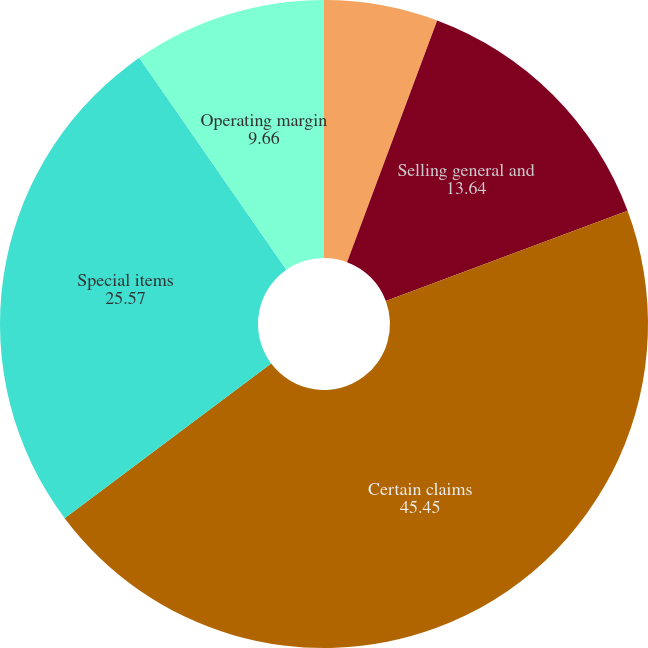<chart> <loc_0><loc_0><loc_500><loc_500><pie_chart><fcel>Research and development<fcel>Selling general and<fcel>Certain claims<fcel>Special items<fcel>Operating margin<nl><fcel>5.68%<fcel>13.64%<fcel>45.45%<fcel>25.57%<fcel>9.66%<nl></chart> 